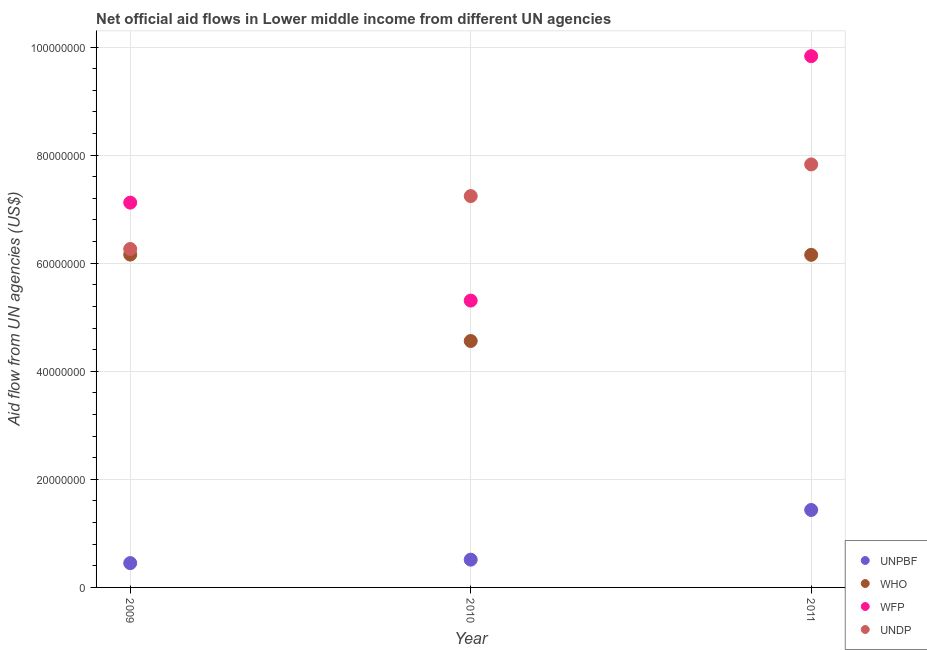Is the number of dotlines equal to the number of legend labels?
Provide a short and direct response. Yes. What is the amount of aid given by who in 2011?
Offer a very short reply. 6.16e+07. Across all years, what is the maximum amount of aid given by unpbf?
Give a very brief answer. 1.43e+07. Across all years, what is the minimum amount of aid given by undp?
Your answer should be very brief. 6.26e+07. In which year was the amount of aid given by who maximum?
Give a very brief answer. 2009. What is the total amount of aid given by wfp in the graph?
Make the answer very short. 2.23e+08. What is the difference between the amount of aid given by wfp in 2010 and that in 2011?
Make the answer very short. -4.52e+07. What is the difference between the amount of aid given by undp in 2011 and the amount of aid given by wfp in 2009?
Ensure brevity in your answer.  7.07e+06. What is the average amount of aid given by undp per year?
Give a very brief answer. 7.11e+07. In the year 2009, what is the difference between the amount of aid given by wfp and amount of aid given by who?
Keep it short and to the point. 9.62e+06. In how many years, is the amount of aid given by who greater than 64000000 US$?
Provide a short and direct response. 0. What is the ratio of the amount of aid given by unpbf in 2010 to that in 2011?
Offer a terse response. 0.36. What is the difference between the highest and the second highest amount of aid given by undp?
Give a very brief answer. 5.86e+06. What is the difference between the highest and the lowest amount of aid given by who?
Give a very brief answer. 1.60e+07. Is the sum of the amount of aid given by who in 2010 and 2011 greater than the maximum amount of aid given by unpbf across all years?
Your answer should be compact. Yes. Is it the case that in every year, the sum of the amount of aid given by undp and amount of aid given by who is greater than the sum of amount of aid given by wfp and amount of aid given by unpbf?
Keep it short and to the point. No. Does the amount of aid given by who monotonically increase over the years?
Your response must be concise. No. Is the amount of aid given by undp strictly greater than the amount of aid given by who over the years?
Ensure brevity in your answer.  Yes. Is the amount of aid given by unpbf strictly less than the amount of aid given by undp over the years?
Provide a short and direct response. Yes. How many dotlines are there?
Offer a very short reply. 4. What is the difference between two consecutive major ticks on the Y-axis?
Offer a terse response. 2.00e+07. How many legend labels are there?
Provide a succinct answer. 4. What is the title of the graph?
Offer a terse response. Net official aid flows in Lower middle income from different UN agencies. Does "Water" appear as one of the legend labels in the graph?
Give a very brief answer. No. What is the label or title of the X-axis?
Your answer should be compact. Year. What is the label or title of the Y-axis?
Provide a succinct answer. Aid flow from UN agencies (US$). What is the Aid flow from UN agencies (US$) of UNPBF in 2009?
Offer a very short reply. 4.50e+06. What is the Aid flow from UN agencies (US$) of WHO in 2009?
Offer a terse response. 6.16e+07. What is the Aid flow from UN agencies (US$) in WFP in 2009?
Your response must be concise. 7.12e+07. What is the Aid flow from UN agencies (US$) of UNDP in 2009?
Make the answer very short. 6.26e+07. What is the Aid flow from UN agencies (US$) of UNPBF in 2010?
Keep it short and to the point. 5.14e+06. What is the Aid flow from UN agencies (US$) of WHO in 2010?
Offer a terse response. 4.56e+07. What is the Aid flow from UN agencies (US$) in WFP in 2010?
Provide a succinct answer. 5.31e+07. What is the Aid flow from UN agencies (US$) of UNDP in 2010?
Provide a succinct answer. 7.24e+07. What is the Aid flow from UN agencies (US$) of UNPBF in 2011?
Offer a terse response. 1.43e+07. What is the Aid flow from UN agencies (US$) of WHO in 2011?
Ensure brevity in your answer.  6.16e+07. What is the Aid flow from UN agencies (US$) of WFP in 2011?
Your answer should be very brief. 9.83e+07. What is the Aid flow from UN agencies (US$) in UNDP in 2011?
Give a very brief answer. 7.83e+07. Across all years, what is the maximum Aid flow from UN agencies (US$) in UNPBF?
Provide a succinct answer. 1.43e+07. Across all years, what is the maximum Aid flow from UN agencies (US$) of WHO?
Your answer should be compact. 6.16e+07. Across all years, what is the maximum Aid flow from UN agencies (US$) in WFP?
Offer a very short reply. 9.83e+07. Across all years, what is the maximum Aid flow from UN agencies (US$) of UNDP?
Your response must be concise. 7.83e+07. Across all years, what is the minimum Aid flow from UN agencies (US$) of UNPBF?
Offer a terse response. 4.50e+06. Across all years, what is the minimum Aid flow from UN agencies (US$) in WHO?
Your response must be concise. 4.56e+07. Across all years, what is the minimum Aid flow from UN agencies (US$) of WFP?
Make the answer very short. 5.31e+07. Across all years, what is the minimum Aid flow from UN agencies (US$) of UNDP?
Keep it short and to the point. 6.26e+07. What is the total Aid flow from UN agencies (US$) in UNPBF in the graph?
Provide a short and direct response. 2.40e+07. What is the total Aid flow from UN agencies (US$) in WHO in the graph?
Your answer should be very brief. 1.69e+08. What is the total Aid flow from UN agencies (US$) in WFP in the graph?
Your response must be concise. 2.23e+08. What is the total Aid flow from UN agencies (US$) of UNDP in the graph?
Provide a short and direct response. 2.13e+08. What is the difference between the Aid flow from UN agencies (US$) in UNPBF in 2009 and that in 2010?
Keep it short and to the point. -6.40e+05. What is the difference between the Aid flow from UN agencies (US$) in WHO in 2009 and that in 2010?
Give a very brief answer. 1.60e+07. What is the difference between the Aid flow from UN agencies (US$) of WFP in 2009 and that in 2010?
Offer a terse response. 1.81e+07. What is the difference between the Aid flow from UN agencies (US$) of UNDP in 2009 and that in 2010?
Your answer should be very brief. -9.79e+06. What is the difference between the Aid flow from UN agencies (US$) in UNPBF in 2009 and that in 2011?
Your answer should be compact. -9.83e+06. What is the difference between the Aid flow from UN agencies (US$) of WFP in 2009 and that in 2011?
Your answer should be very brief. -2.71e+07. What is the difference between the Aid flow from UN agencies (US$) in UNDP in 2009 and that in 2011?
Give a very brief answer. -1.56e+07. What is the difference between the Aid flow from UN agencies (US$) of UNPBF in 2010 and that in 2011?
Make the answer very short. -9.19e+06. What is the difference between the Aid flow from UN agencies (US$) of WHO in 2010 and that in 2011?
Your response must be concise. -1.60e+07. What is the difference between the Aid flow from UN agencies (US$) in WFP in 2010 and that in 2011?
Provide a short and direct response. -4.52e+07. What is the difference between the Aid flow from UN agencies (US$) of UNDP in 2010 and that in 2011?
Your response must be concise. -5.86e+06. What is the difference between the Aid flow from UN agencies (US$) in UNPBF in 2009 and the Aid flow from UN agencies (US$) in WHO in 2010?
Offer a very short reply. -4.11e+07. What is the difference between the Aid flow from UN agencies (US$) of UNPBF in 2009 and the Aid flow from UN agencies (US$) of WFP in 2010?
Your response must be concise. -4.86e+07. What is the difference between the Aid flow from UN agencies (US$) of UNPBF in 2009 and the Aid flow from UN agencies (US$) of UNDP in 2010?
Your response must be concise. -6.79e+07. What is the difference between the Aid flow from UN agencies (US$) in WHO in 2009 and the Aid flow from UN agencies (US$) in WFP in 2010?
Give a very brief answer. 8.51e+06. What is the difference between the Aid flow from UN agencies (US$) of WHO in 2009 and the Aid flow from UN agencies (US$) of UNDP in 2010?
Ensure brevity in your answer.  -1.08e+07. What is the difference between the Aid flow from UN agencies (US$) of WFP in 2009 and the Aid flow from UN agencies (US$) of UNDP in 2010?
Your answer should be compact. -1.21e+06. What is the difference between the Aid flow from UN agencies (US$) in UNPBF in 2009 and the Aid flow from UN agencies (US$) in WHO in 2011?
Offer a terse response. -5.70e+07. What is the difference between the Aid flow from UN agencies (US$) of UNPBF in 2009 and the Aid flow from UN agencies (US$) of WFP in 2011?
Your response must be concise. -9.38e+07. What is the difference between the Aid flow from UN agencies (US$) in UNPBF in 2009 and the Aid flow from UN agencies (US$) in UNDP in 2011?
Keep it short and to the point. -7.38e+07. What is the difference between the Aid flow from UN agencies (US$) of WHO in 2009 and the Aid flow from UN agencies (US$) of WFP in 2011?
Your answer should be compact. -3.67e+07. What is the difference between the Aid flow from UN agencies (US$) of WHO in 2009 and the Aid flow from UN agencies (US$) of UNDP in 2011?
Provide a succinct answer. -1.67e+07. What is the difference between the Aid flow from UN agencies (US$) of WFP in 2009 and the Aid flow from UN agencies (US$) of UNDP in 2011?
Provide a short and direct response. -7.07e+06. What is the difference between the Aid flow from UN agencies (US$) in UNPBF in 2010 and the Aid flow from UN agencies (US$) in WHO in 2011?
Ensure brevity in your answer.  -5.64e+07. What is the difference between the Aid flow from UN agencies (US$) of UNPBF in 2010 and the Aid flow from UN agencies (US$) of WFP in 2011?
Give a very brief answer. -9.32e+07. What is the difference between the Aid flow from UN agencies (US$) of UNPBF in 2010 and the Aid flow from UN agencies (US$) of UNDP in 2011?
Offer a very short reply. -7.31e+07. What is the difference between the Aid flow from UN agencies (US$) of WHO in 2010 and the Aid flow from UN agencies (US$) of WFP in 2011?
Your answer should be very brief. -5.27e+07. What is the difference between the Aid flow from UN agencies (US$) of WHO in 2010 and the Aid flow from UN agencies (US$) of UNDP in 2011?
Your answer should be very brief. -3.27e+07. What is the difference between the Aid flow from UN agencies (US$) in WFP in 2010 and the Aid flow from UN agencies (US$) in UNDP in 2011?
Provide a succinct answer. -2.52e+07. What is the average Aid flow from UN agencies (US$) in UNPBF per year?
Make the answer very short. 7.99e+06. What is the average Aid flow from UN agencies (US$) in WHO per year?
Your answer should be very brief. 5.62e+07. What is the average Aid flow from UN agencies (US$) in WFP per year?
Make the answer very short. 7.42e+07. What is the average Aid flow from UN agencies (US$) of UNDP per year?
Your answer should be very brief. 7.11e+07. In the year 2009, what is the difference between the Aid flow from UN agencies (US$) in UNPBF and Aid flow from UN agencies (US$) in WHO?
Provide a succinct answer. -5.71e+07. In the year 2009, what is the difference between the Aid flow from UN agencies (US$) of UNPBF and Aid flow from UN agencies (US$) of WFP?
Provide a short and direct response. -6.67e+07. In the year 2009, what is the difference between the Aid flow from UN agencies (US$) in UNPBF and Aid flow from UN agencies (US$) in UNDP?
Offer a very short reply. -5.81e+07. In the year 2009, what is the difference between the Aid flow from UN agencies (US$) in WHO and Aid flow from UN agencies (US$) in WFP?
Provide a short and direct response. -9.62e+06. In the year 2009, what is the difference between the Aid flow from UN agencies (US$) of WHO and Aid flow from UN agencies (US$) of UNDP?
Offer a terse response. -1.04e+06. In the year 2009, what is the difference between the Aid flow from UN agencies (US$) in WFP and Aid flow from UN agencies (US$) in UNDP?
Ensure brevity in your answer.  8.58e+06. In the year 2010, what is the difference between the Aid flow from UN agencies (US$) of UNPBF and Aid flow from UN agencies (US$) of WHO?
Provide a short and direct response. -4.05e+07. In the year 2010, what is the difference between the Aid flow from UN agencies (US$) in UNPBF and Aid flow from UN agencies (US$) in WFP?
Offer a terse response. -4.79e+07. In the year 2010, what is the difference between the Aid flow from UN agencies (US$) of UNPBF and Aid flow from UN agencies (US$) of UNDP?
Keep it short and to the point. -6.73e+07. In the year 2010, what is the difference between the Aid flow from UN agencies (US$) in WHO and Aid flow from UN agencies (US$) in WFP?
Your answer should be very brief. -7.48e+06. In the year 2010, what is the difference between the Aid flow from UN agencies (US$) in WHO and Aid flow from UN agencies (US$) in UNDP?
Ensure brevity in your answer.  -2.68e+07. In the year 2010, what is the difference between the Aid flow from UN agencies (US$) of WFP and Aid flow from UN agencies (US$) of UNDP?
Make the answer very short. -1.93e+07. In the year 2011, what is the difference between the Aid flow from UN agencies (US$) in UNPBF and Aid flow from UN agencies (US$) in WHO?
Provide a short and direct response. -4.72e+07. In the year 2011, what is the difference between the Aid flow from UN agencies (US$) in UNPBF and Aid flow from UN agencies (US$) in WFP?
Give a very brief answer. -8.40e+07. In the year 2011, what is the difference between the Aid flow from UN agencies (US$) in UNPBF and Aid flow from UN agencies (US$) in UNDP?
Provide a short and direct response. -6.40e+07. In the year 2011, what is the difference between the Aid flow from UN agencies (US$) in WHO and Aid flow from UN agencies (US$) in WFP?
Provide a succinct answer. -3.68e+07. In the year 2011, what is the difference between the Aid flow from UN agencies (US$) in WHO and Aid flow from UN agencies (US$) in UNDP?
Give a very brief answer. -1.67e+07. In the year 2011, what is the difference between the Aid flow from UN agencies (US$) in WFP and Aid flow from UN agencies (US$) in UNDP?
Your answer should be compact. 2.00e+07. What is the ratio of the Aid flow from UN agencies (US$) of UNPBF in 2009 to that in 2010?
Make the answer very short. 0.88. What is the ratio of the Aid flow from UN agencies (US$) of WHO in 2009 to that in 2010?
Provide a succinct answer. 1.35. What is the ratio of the Aid flow from UN agencies (US$) of WFP in 2009 to that in 2010?
Provide a short and direct response. 1.34. What is the ratio of the Aid flow from UN agencies (US$) of UNDP in 2009 to that in 2010?
Offer a very short reply. 0.86. What is the ratio of the Aid flow from UN agencies (US$) of UNPBF in 2009 to that in 2011?
Offer a very short reply. 0.31. What is the ratio of the Aid flow from UN agencies (US$) of WFP in 2009 to that in 2011?
Offer a very short reply. 0.72. What is the ratio of the Aid flow from UN agencies (US$) of UNDP in 2009 to that in 2011?
Keep it short and to the point. 0.8. What is the ratio of the Aid flow from UN agencies (US$) in UNPBF in 2010 to that in 2011?
Offer a terse response. 0.36. What is the ratio of the Aid flow from UN agencies (US$) in WHO in 2010 to that in 2011?
Give a very brief answer. 0.74. What is the ratio of the Aid flow from UN agencies (US$) of WFP in 2010 to that in 2011?
Give a very brief answer. 0.54. What is the ratio of the Aid flow from UN agencies (US$) in UNDP in 2010 to that in 2011?
Provide a short and direct response. 0.93. What is the difference between the highest and the second highest Aid flow from UN agencies (US$) of UNPBF?
Provide a short and direct response. 9.19e+06. What is the difference between the highest and the second highest Aid flow from UN agencies (US$) in WFP?
Your response must be concise. 2.71e+07. What is the difference between the highest and the second highest Aid flow from UN agencies (US$) of UNDP?
Keep it short and to the point. 5.86e+06. What is the difference between the highest and the lowest Aid flow from UN agencies (US$) in UNPBF?
Your response must be concise. 9.83e+06. What is the difference between the highest and the lowest Aid flow from UN agencies (US$) of WHO?
Provide a succinct answer. 1.60e+07. What is the difference between the highest and the lowest Aid flow from UN agencies (US$) of WFP?
Your answer should be very brief. 4.52e+07. What is the difference between the highest and the lowest Aid flow from UN agencies (US$) of UNDP?
Your answer should be very brief. 1.56e+07. 